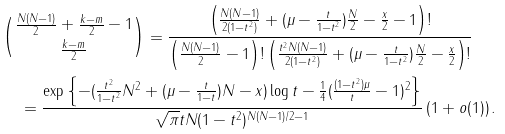<formula> <loc_0><loc_0><loc_500><loc_500>& \binom { \frac { N ( N - 1 ) } { 2 } + \frac { k - m } 2 - 1 } { \frac { k - m } 2 } = \frac { \left ( \frac { N ( N - 1 ) } { 2 ( 1 - t ^ { 2 } ) } + ( \mu - \frac { t } { 1 - t ^ { 2 } } ) \frac { N } 2 - \frac { x } 2 - 1 \right ) ! } { \left ( \frac { N ( N - 1 ) } { 2 } - 1 \right ) ! \left ( \frac { t ^ { 2 } N ( N - 1 ) } { 2 ( 1 - t ^ { 2 } ) } + ( \mu - \frac { t } { 1 - t ^ { 2 } } ) \frac { N } 2 - \frac { x } 2 \right ) ! } \\ & \quad = \frac { \exp \left \{ - ( \frac { t ^ { 2 } } { 1 - t ^ { 2 } } N ^ { 2 } + ( \mu - \frac { t } { 1 - t } ) N - x ) \log t - \frac { 1 } { 4 } ( \frac { ( 1 - t ^ { 2 } ) \mu } { t } - 1 ) ^ { 2 } \right \} } { \sqrt { \pi } t N ( 1 - t ^ { 2 } ) ^ { N ( N - 1 ) / 2 - 1 } } \left ( 1 + o ( 1 ) \right ) .</formula> 